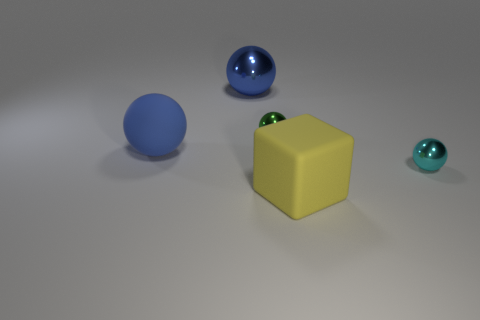Subtract 2 balls. How many balls are left? 2 Subtract all cyan balls. How many balls are left? 3 Subtract all green balls. How many balls are left? 3 Add 1 small cyan balls. How many objects exist? 6 Subtract all purple spheres. Subtract all brown blocks. How many spheres are left? 4 Subtract all blocks. How many objects are left? 4 Add 3 cyan balls. How many cyan balls are left? 4 Add 1 metallic cylinders. How many metallic cylinders exist? 1 Subtract 0 red spheres. How many objects are left? 5 Subtract all blue rubber things. Subtract all tiny balls. How many objects are left? 2 